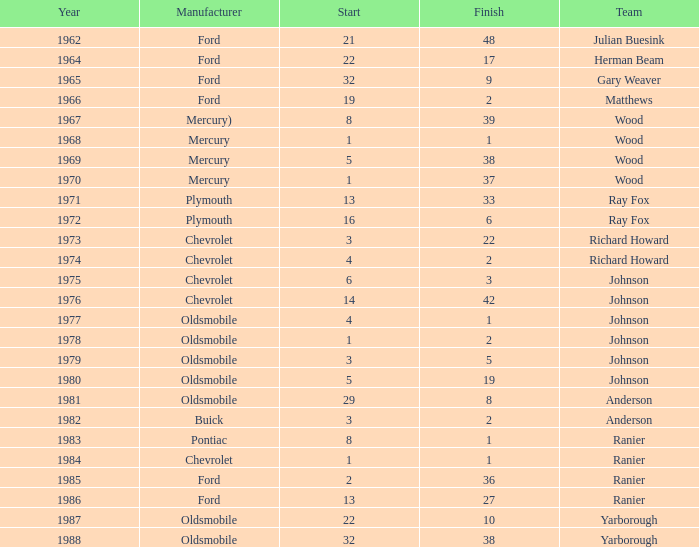Who was the maufacturer of the vehicle during the race where Cale Yarborough started at 19 and finished earlier than 42? Ford. 